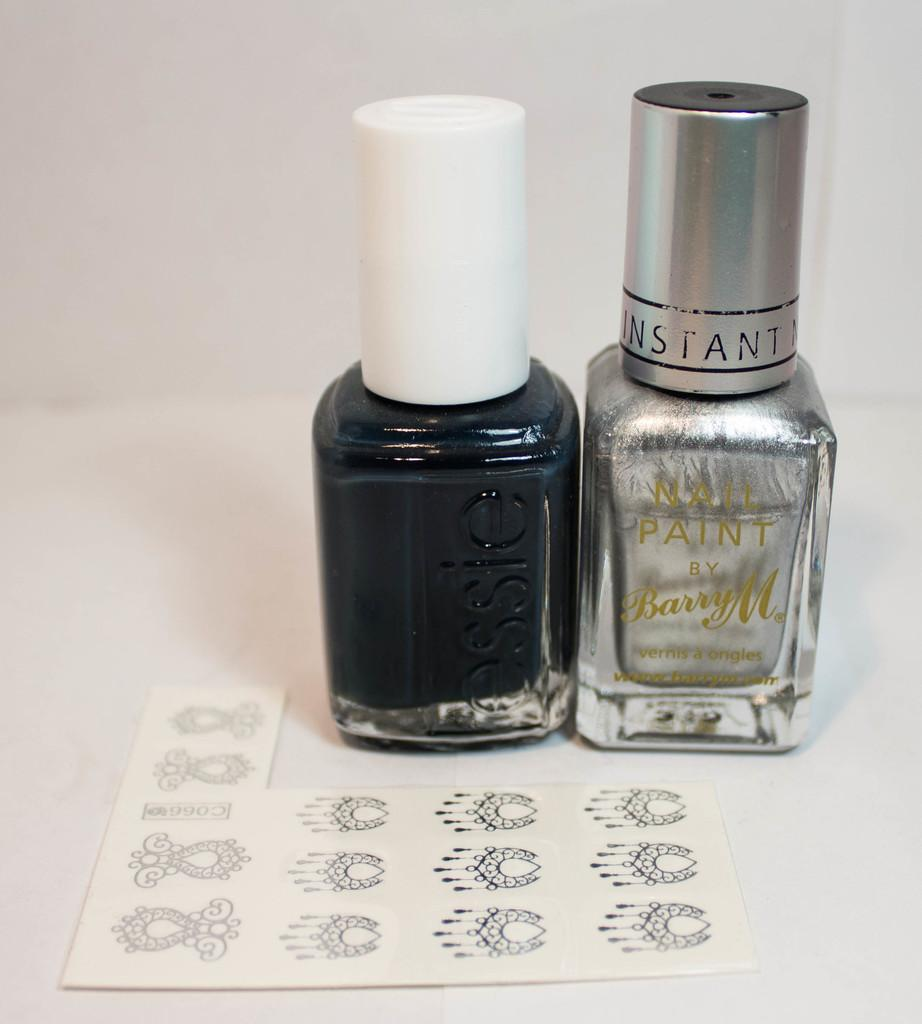Provide a one-sentence caption for the provided image. Two bottles of nail polish, one black and one silver, with the logo instant on the silver one. 